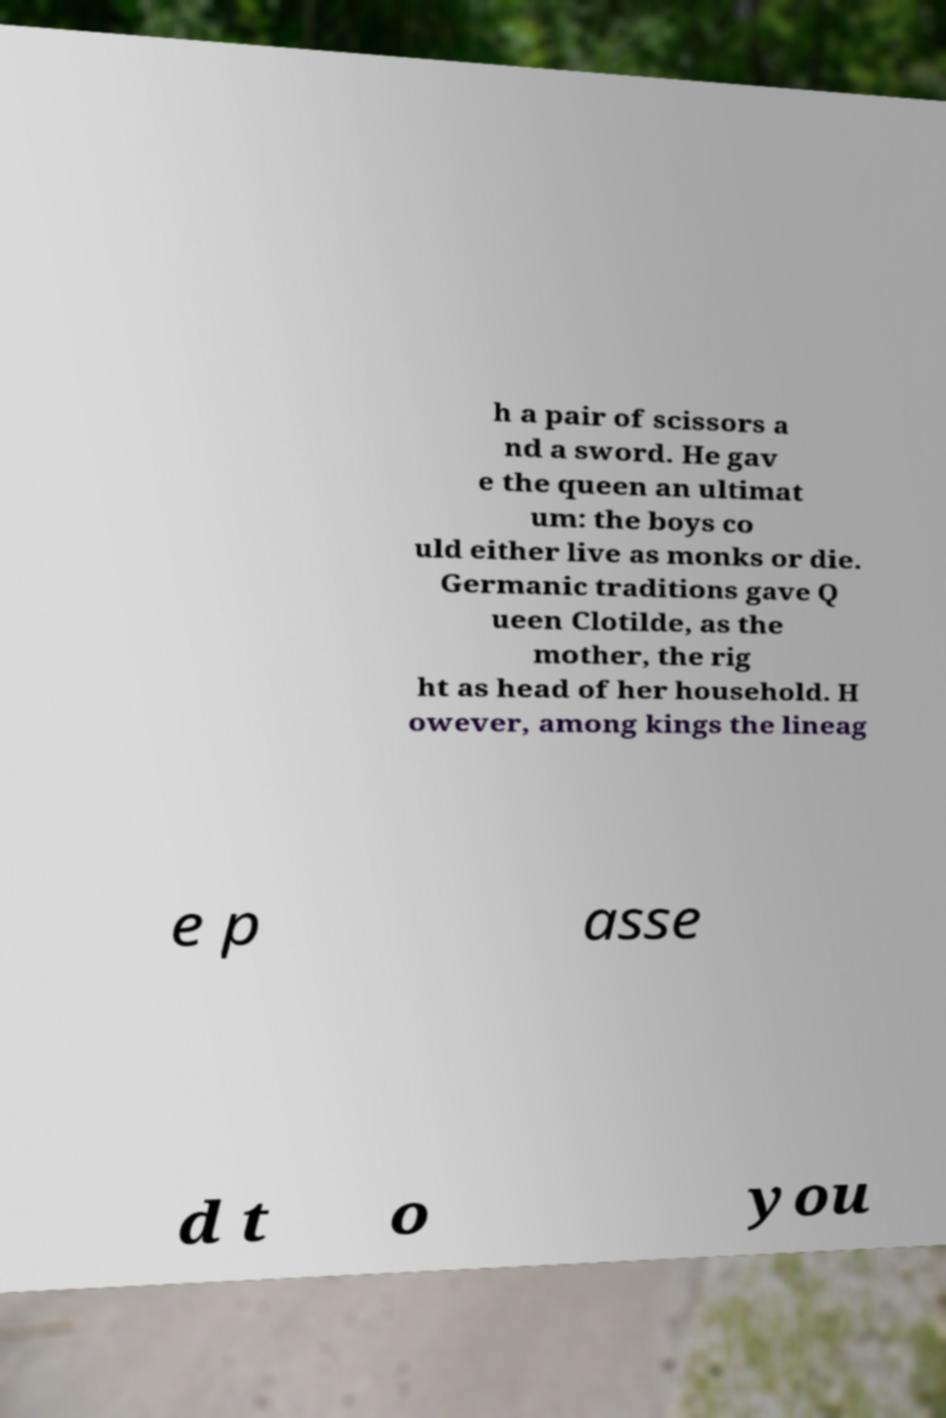I need the written content from this picture converted into text. Can you do that? h a pair of scissors a nd a sword. He gav e the queen an ultimat um: the boys co uld either live as monks or die. Germanic traditions gave Q ueen Clotilde, as the mother, the rig ht as head of her household. H owever, among kings the lineag e p asse d t o you 